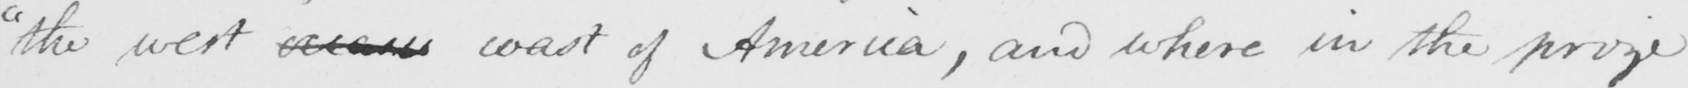What text is written in this handwritten line? " the west ocean coast of America , and where in the prize 